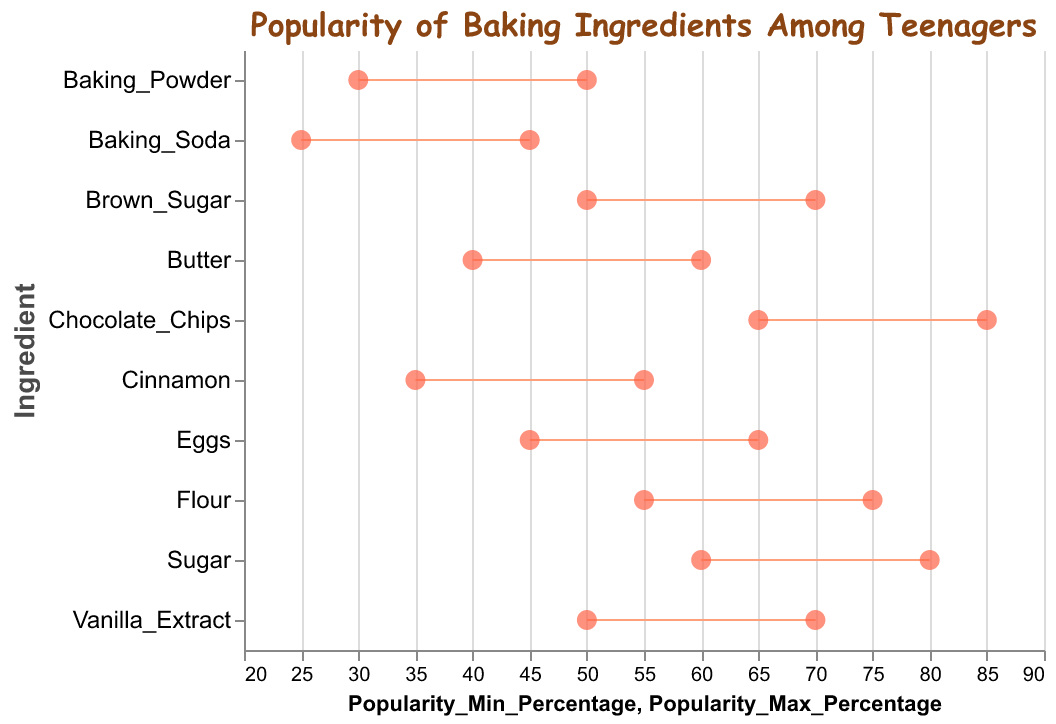What's the title of the plot? The title is visibly stated at the top of the plot.
Answer: Popularity of Baking Ingredients Among Teenagers Which ingredient has the smallest range of popularity percentages? The range of popularity for each ingredient can be calculated by subtracting the minimum percentage from the maximum percentage. The ingredient with the smallest difference is Vanilla Extract (70 - 50 = 20).
Answer: Vanilla Extract Which ingredient is the most popular among teenagers? To find the most popular ingredient, we look for the ingredient with the highest maximum popularity percentage. In this plot, it is Chocolate Chips with a max popularity of 85%.
Answer: Chocolate Chips How much more popular is the maximum popularity of Sugar compared to Baking Soda? We find the max popularity for both ingredients (Sugar: 80%, Baking Soda: 45%) and subtract the values. 80 - 45 = 35.
Answer: 35% Which ingredient shows a minimum popularity of 40%? We look for the ingredient which has a dot at the 40% mark on the x-axis. It is Butter.
Answer: Butter What is the average popularity range of Cinnamon? To find the average, sum the min and max percentages of Cinnamon, then divide by 2. (35 + 55) / 2 = 45.
Answer: 45% Which three ingredients have a minimum popularity percentage lower than 40%? By checking the min popularity percentages, the three ingredients are Baking Powder (30%), Baking Soda (25%), and Cinnamon (35%).
Answer: Baking Powder, Baking Soda, Cinnamon Which ingredients have the same popularity maximum percentage? We check the max percentages and find that Vanilla Extract and Brown Sugar both have a max of 70%.
Answer: Vanilla Extract, Brown Sugar What is the difference in the maximum popularity percentages between Flour and Eggs? Flour has a maximum popularity of 75%, and Eggs have a maximum of 65%. The difference is 75 - 65 = 10%.
Answer: 10% Which ingredient is found between Vanilla Extract and Sugar on the y-axis? Referring to the sorting of ingredients on the y-axis, the ingredient between Vanilla Extract (50-70%) and Sugar (60-80%) is Butter (40-60%).
Answer: Butter 